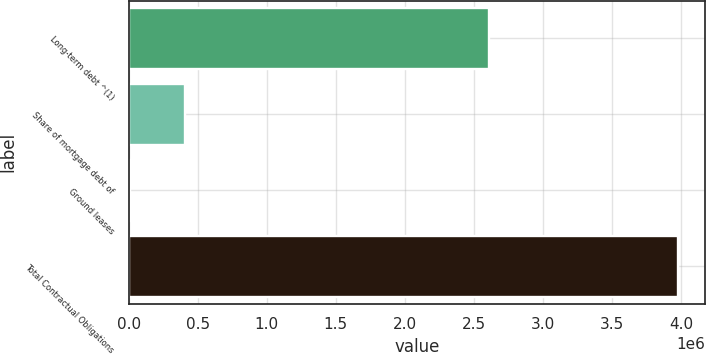<chart> <loc_0><loc_0><loc_500><loc_500><bar_chart><fcel>Long-term debt ^(1)<fcel>Share of mortgage debt of<fcel>Ground leases<fcel>Total Contractual Obligations<nl><fcel>2.61062e+06<fcel>405454<fcel>8973<fcel>3.97379e+06<nl></chart> 